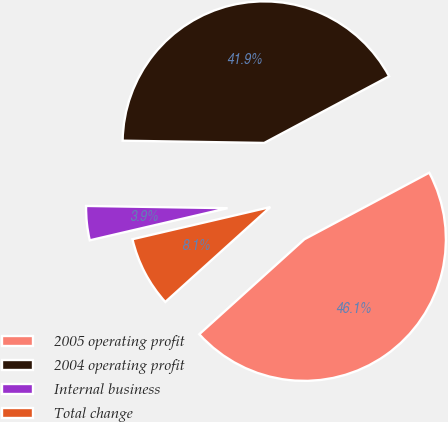Convert chart to OTSL. <chart><loc_0><loc_0><loc_500><loc_500><pie_chart><fcel>2005 operating profit<fcel>2004 operating profit<fcel>Internal business<fcel>Total change<nl><fcel>46.1%<fcel>41.95%<fcel>3.9%<fcel>8.05%<nl></chart> 